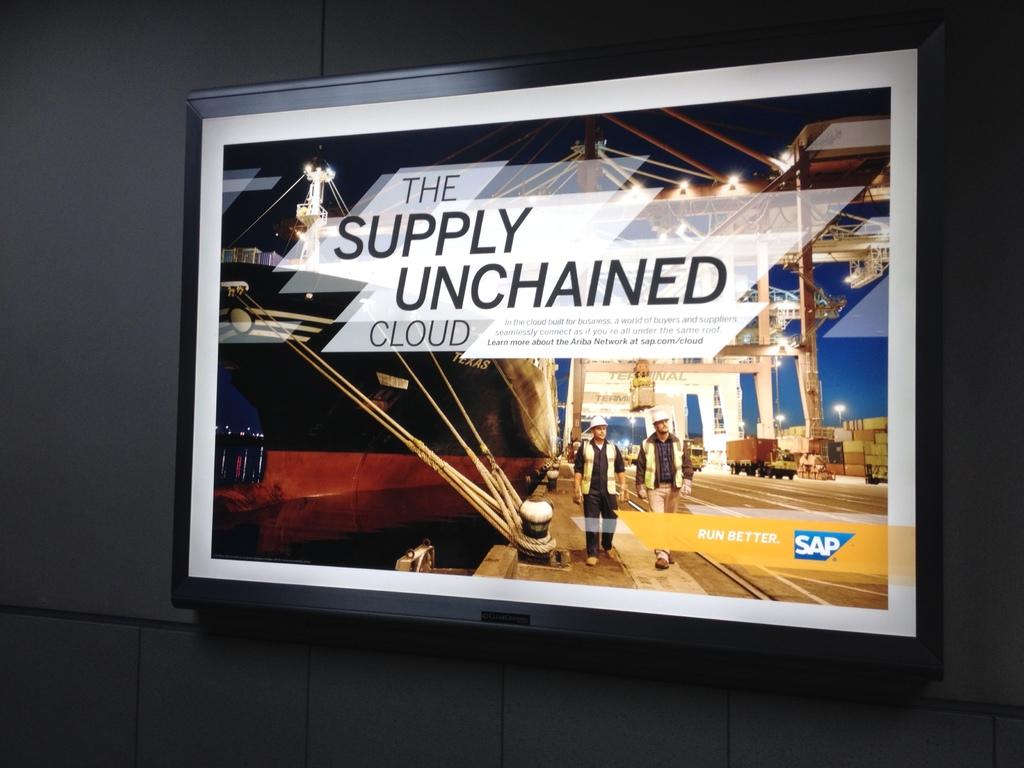What does the sign say?
Your answer should be very brief. The supply unchained cloud. 